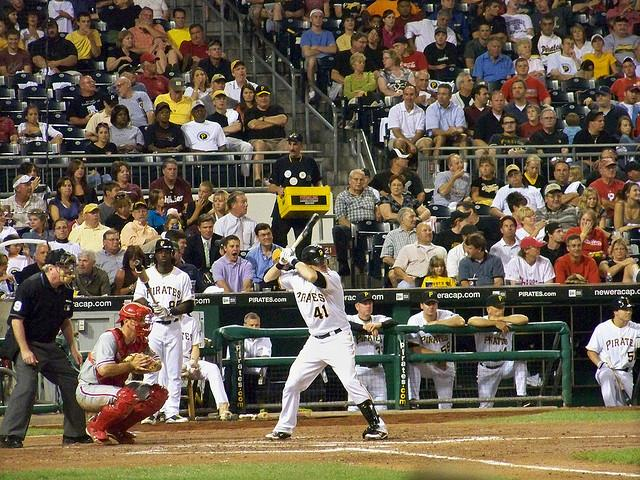What number is the batter wearing? Please explain your reasoning. 41. The number is 41. 